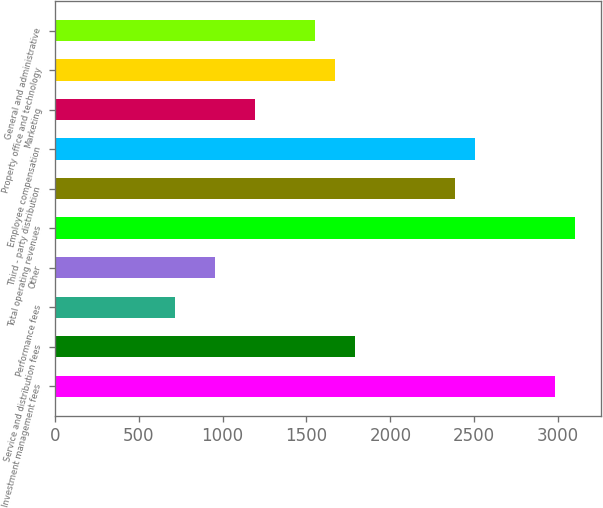Convert chart. <chart><loc_0><loc_0><loc_500><loc_500><bar_chart><fcel>Investment management fees<fcel>Service and distribution fees<fcel>Performance fees<fcel>Other<fcel>Total operating revenues<fcel>Third - party distribution<fcel>Employee compensation<fcel>Marketing<fcel>Property office and technology<fcel>General and administrative<nl><fcel>2981.03<fcel>1788.73<fcel>715.66<fcel>954.12<fcel>3100.26<fcel>2384.88<fcel>2504.11<fcel>1192.58<fcel>1669.5<fcel>1550.27<nl></chart> 